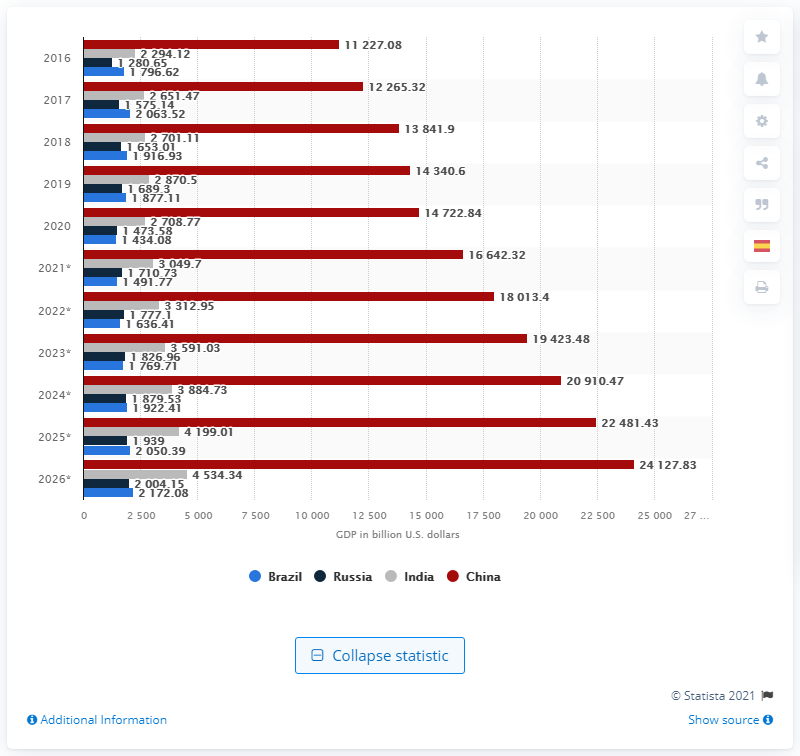Highlight a few significant elements in this photo. The GDP of the BRIC country with the second lowest among the four was Russia. 